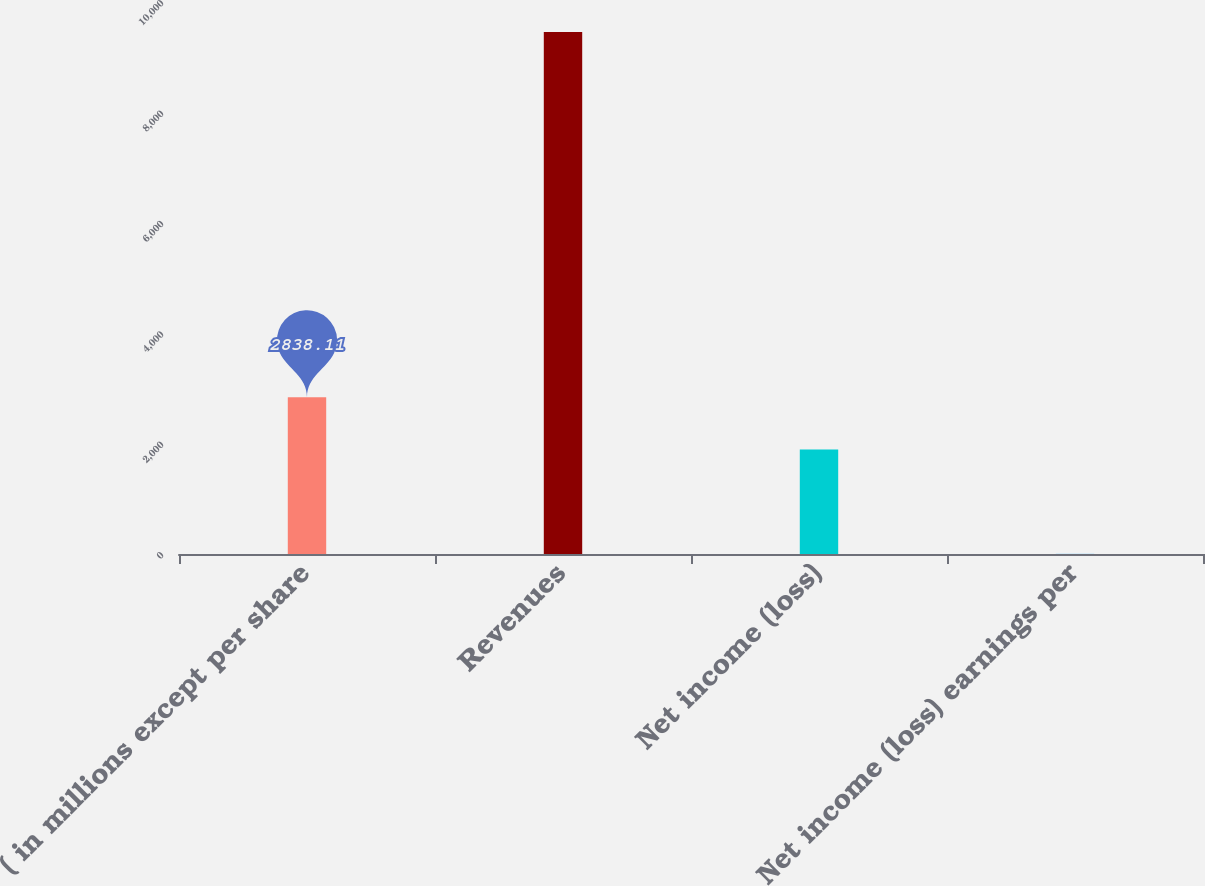Convert chart. <chart><loc_0><loc_0><loc_500><loc_500><bar_chart><fcel>( in millions except per share<fcel>Revenues<fcel>Net income (loss)<fcel>Net income (loss) earnings per<nl><fcel>2838.11<fcel>9455<fcel>1892.84<fcel>2.3<nl></chart> 